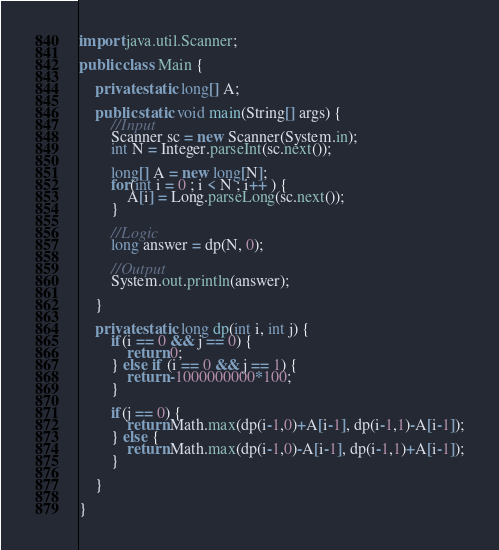<code> <loc_0><loc_0><loc_500><loc_500><_Java_>import java.util.Scanner;

public class Main {

	private static long[] A;

	public static void main(String[] args) {
		//Input
		Scanner sc = new Scanner(System.in);
		int N = Integer.parseInt(sc.next());

		long[] A = new long[N];
		for(int i = 0 ; i < N ; i++ ) {
			A[i] = Long.parseLong(sc.next());
		}

		//Logic
		long answer = dp(N, 0);

		//Output
		System.out.println(answer);

	}

	private static long dp(int i, int j) {
		if(i == 0 && j == 0) {
			return 0;
		} else if (i == 0 && j == 1) {
			return -1000000000*100;
		}

		if(j == 0) {
			return Math.max(dp(i-1,0)+A[i-1], dp(i-1,1)-A[i-1]);
		} else {
			return Math.max(dp(i-1,0)-A[i-1], dp(i-1,1)+A[i-1]);
		}

	}

}
</code> 